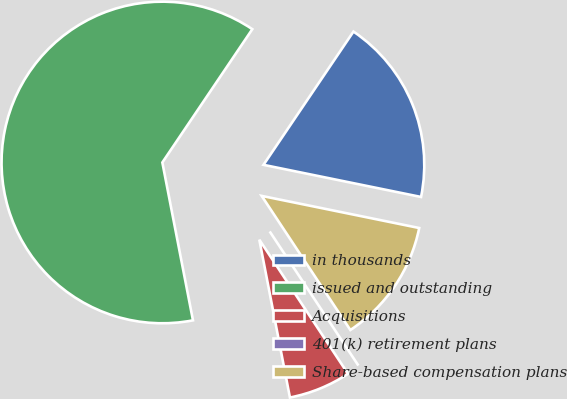Convert chart. <chart><loc_0><loc_0><loc_500><loc_500><pie_chart><fcel>in thousands<fcel>issued and outstanding<fcel>Acquisitions<fcel>401(k) retirement plans<fcel>Share-based compensation plans<nl><fcel>18.75%<fcel>62.5%<fcel>6.25%<fcel>0.0%<fcel>12.5%<nl></chart> 